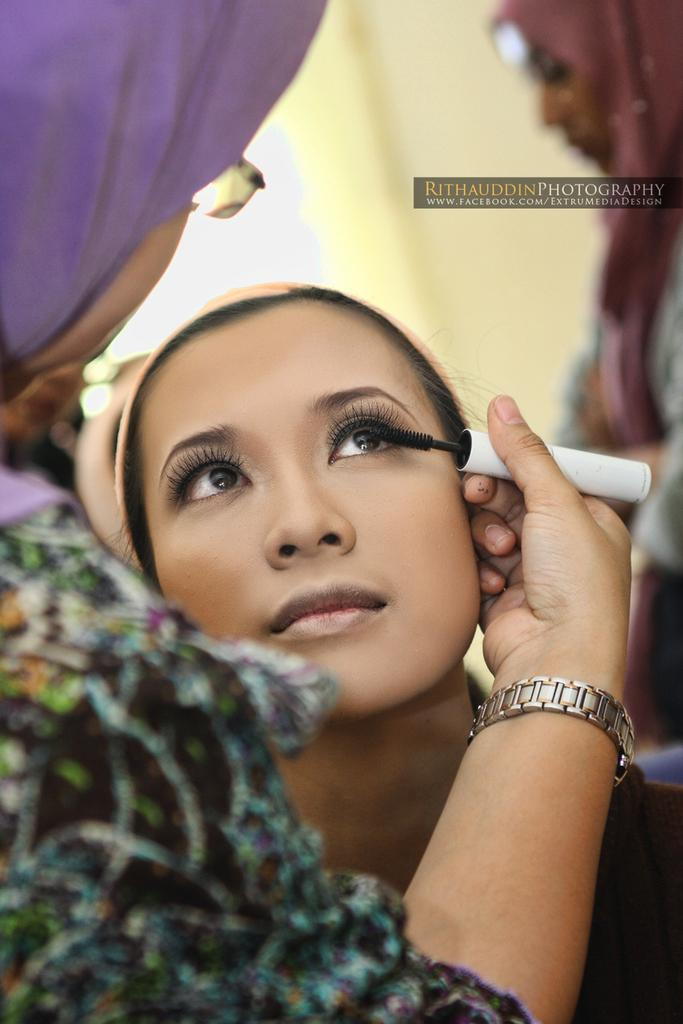What is happening between the two ladies in the image? There is a lady applying mascara to another lady in the image. Where is the lady applying mascara located in relation to the other lady? The lady applying mascara is on the left side of the image, while the lady receiving the mascara is sitting in front of her. Can you describe the background of the image? There is a wall in the background of the image. Are there any other people visible in the image? Yes, there is another lady in the top right corner of the image. What type of letter is the lady in the top right corner of the image writing? There is no letter or writing activity visible in the image. How many tomatoes are on the table in the image? There are no tomatoes present in the image. 